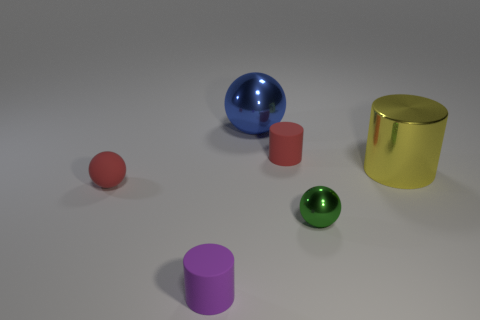Subtract all tiny matte cylinders. How many cylinders are left? 1 Add 6 tiny purple objects. How many tiny purple objects exist? 7 Add 1 tiny brown matte cubes. How many objects exist? 7 Subtract all purple cylinders. How many cylinders are left? 2 Subtract 1 blue balls. How many objects are left? 5 Subtract 2 cylinders. How many cylinders are left? 1 Subtract all blue spheres. Subtract all red cylinders. How many spheres are left? 2 Subtract all cyan blocks. How many blue cylinders are left? 0 Subtract all yellow rubber objects. Subtract all big yellow things. How many objects are left? 5 Add 6 red cylinders. How many red cylinders are left? 7 